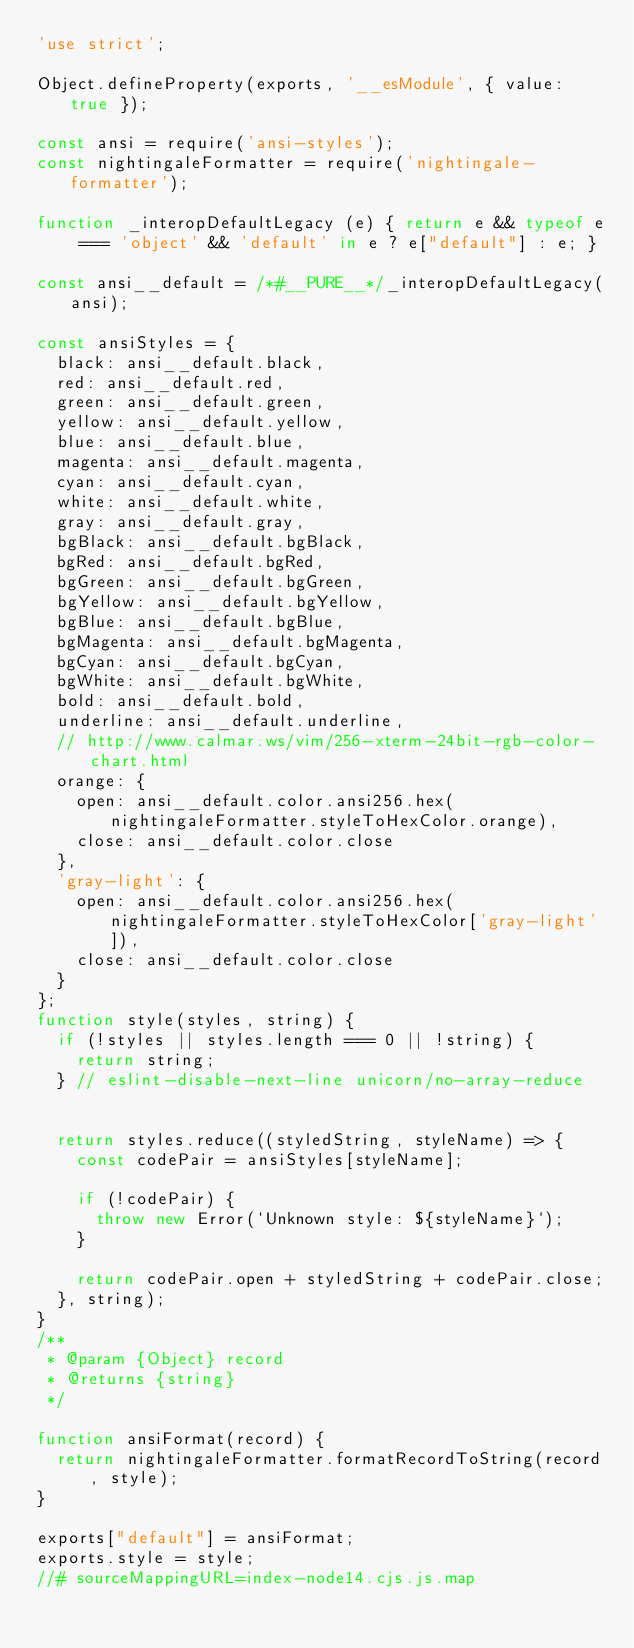<code> <loc_0><loc_0><loc_500><loc_500><_JavaScript_>'use strict';

Object.defineProperty(exports, '__esModule', { value: true });

const ansi = require('ansi-styles');
const nightingaleFormatter = require('nightingale-formatter');

function _interopDefaultLegacy (e) { return e && typeof e === 'object' && 'default' in e ? e["default"] : e; }

const ansi__default = /*#__PURE__*/_interopDefaultLegacy(ansi);

const ansiStyles = {
  black: ansi__default.black,
  red: ansi__default.red,
  green: ansi__default.green,
  yellow: ansi__default.yellow,
  blue: ansi__default.blue,
  magenta: ansi__default.magenta,
  cyan: ansi__default.cyan,
  white: ansi__default.white,
  gray: ansi__default.gray,
  bgBlack: ansi__default.bgBlack,
  bgRed: ansi__default.bgRed,
  bgGreen: ansi__default.bgGreen,
  bgYellow: ansi__default.bgYellow,
  bgBlue: ansi__default.bgBlue,
  bgMagenta: ansi__default.bgMagenta,
  bgCyan: ansi__default.bgCyan,
  bgWhite: ansi__default.bgWhite,
  bold: ansi__default.bold,
  underline: ansi__default.underline,
  // http://www.calmar.ws/vim/256-xterm-24bit-rgb-color-chart.html
  orange: {
    open: ansi__default.color.ansi256.hex(nightingaleFormatter.styleToHexColor.orange),
    close: ansi__default.color.close
  },
  'gray-light': {
    open: ansi__default.color.ansi256.hex(nightingaleFormatter.styleToHexColor['gray-light']),
    close: ansi__default.color.close
  }
};
function style(styles, string) {
  if (!styles || styles.length === 0 || !string) {
    return string;
  } // eslint-disable-next-line unicorn/no-array-reduce


  return styles.reduce((styledString, styleName) => {
    const codePair = ansiStyles[styleName];

    if (!codePair) {
      throw new Error(`Unknown style: ${styleName}`);
    }

    return codePair.open + styledString + codePair.close;
  }, string);
}
/**
 * @param {Object} record
 * @returns {string}
 */

function ansiFormat(record) {
  return nightingaleFormatter.formatRecordToString(record, style);
}

exports["default"] = ansiFormat;
exports.style = style;
//# sourceMappingURL=index-node14.cjs.js.map
</code> 